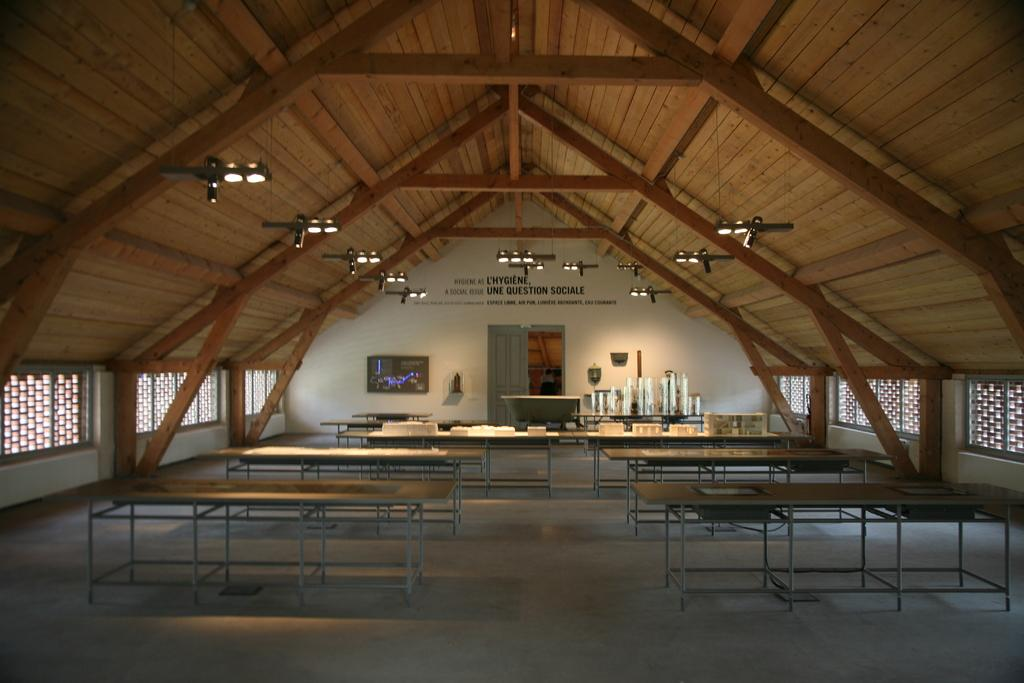What type of furniture is present in the image? There are tables in the image. What items can be seen on the tables? There are plates and glasses on the tables. Where is the entrance to the room or space in the image? There is a door in the image. What provides illumination in the image? There are lights in the image. What type of rice is being used to glue the plates to the tables in the image? There is no rice or glue present in the image, and the plates are not attached to the tables. 